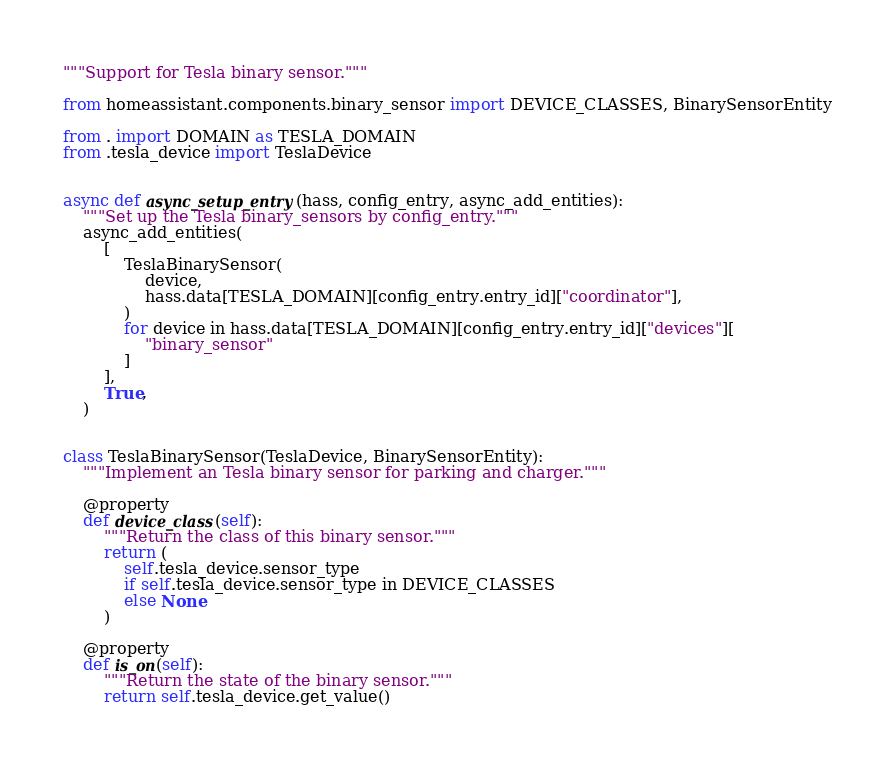<code> <loc_0><loc_0><loc_500><loc_500><_Python_>"""Support for Tesla binary sensor."""

from homeassistant.components.binary_sensor import DEVICE_CLASSES, BinarySensorEntity

from . import DOMAIN as TESLA_DOMAIN
from .tesla_device import TeslaDevice


async def async_setup_entry(hass, config_entry, async_add_entities):
    """Set up the Tesla binary_sensors by config_entry."""
    async_add_entities(
        [
            TeslaBinarySensor(
                device,
                hass.data[TESLA_DOMAIN][config_entry.entry_id]["coordinator"],
            )
            for device in hass.data[TESLA_DOMAIN][config_entry.entry_id]["devices"][
                "binary_sensor"
            ]
        ],
        True,
    )


class TeslaBinarySensor(TeslaDevice, BinarySensorEntity):
    """Implement an Tesla binary sensor for parking and charger."""

    @property
    def device_class(self):
        """Return the class of this binary sensor."""
        return (
            self.tesla_device.sensor_type
            if self.tesla_device.sensor_type in DEVICE_CLASSES
            else None
        )

    @property
    def is_on(self):
        """Return the state of the binary sensor."""
        return self.tesla_device.get_value()
</code> 